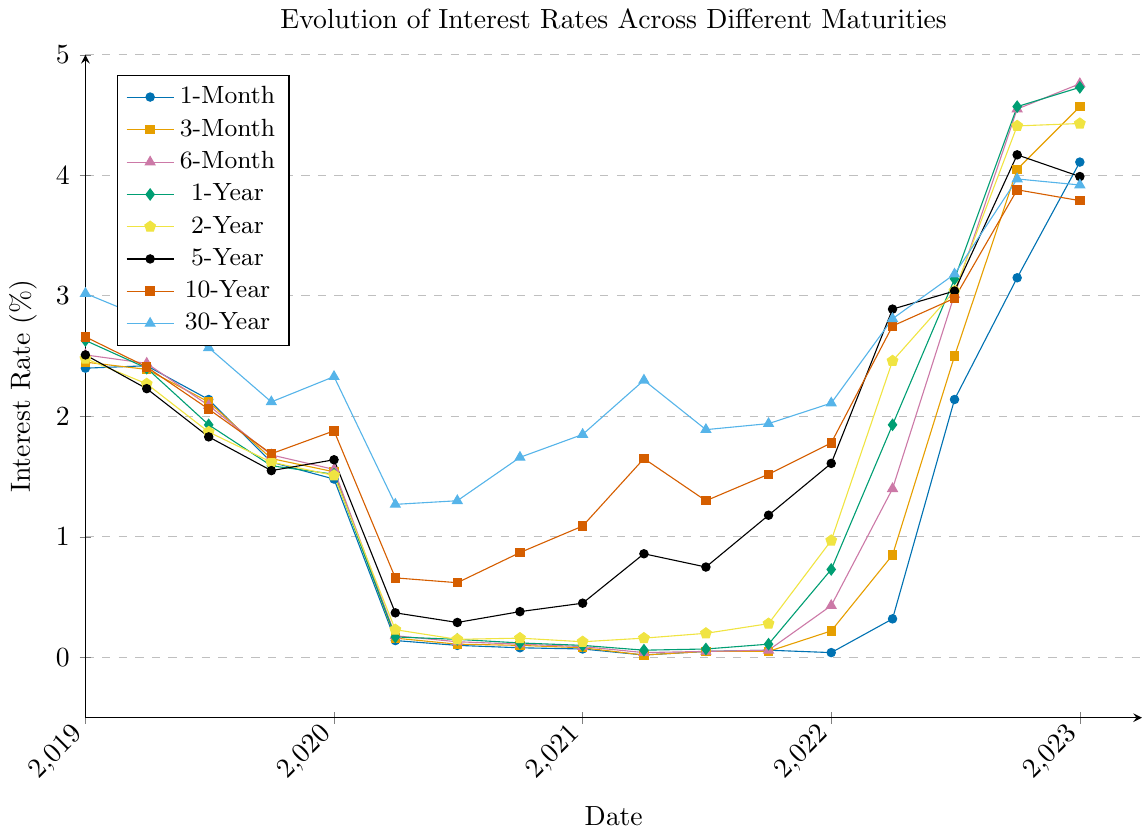Which maturity had the highest interest rate on 2019-01-01? On 2019-01-01, the 30-Year maturity had the highest interest rate. To determine this, look at the data for this date and compare the rates for all maturities.
Answer: 30-Year Which period saw the steepest increase in the 1-Month interest rate? From the figure, observe the 1-Month interest rate line. The steepest increase is between 2022-01-01 and 2023-01-01 as the rate climbs from 0.04 to 4.11.
Answer: 2022-01-01 to 2023-01-01 What was the average interest rate of the 5-Year maturity in 2021? The interest rates for the 5-Year maturity in 2021 are 0.45, 0.86, 0.75, and 1.18. Sum these values (3.24), then divide by 4 (number of data points). Steps: 0.45 + 0.86 + 0.75 + 1.18 = 3.24; 3.24 / 4 = 0.81.
Answer: 0.81 How did the 10-Year interest rate change from 2020-04-01 to 2020-10-01? On 2020-04-01, the 10-Year rate was 0.66, and on 2020-10-01 it was 0.87. The change is calculated as 0.87 - 0.66.
Answer: 0.21 increase Which maturity had the most volatile interest rate throughout the period? Volatility can be gauged by observing the line with the most fluctuations. The 3-Month maturity shows significant ups and downs throughout the chart.
Answer: 3-Month During which year did the 2-Year maturity rate first surpass 1%? From the graph, observe the 2-Year interest rate line. It surpasses 1% in 2022.
Answer: 2022 Which two maturities had the closest interest rates on 2023-01-01? Compare the interest rates for all maturities on 2023-01-01. The 5-Year and 10-Year rates are closest with values 3.99 and 3.79 respectively.
Answer: 5-Year and 10-Year By how much did the 30-Year rate change from 2020-07-01 to 2022-07-01? Check the 30-Year rate on these dates: 1.30 on 2020-07-01 and 3.18 on 2022-07-01. The change is calculated as 3.18 - 1.30.
Answer: 1.88 increase When did the 1-Year interest rate first drop below 1%? On examining the chart for the 1-Year rate, it first drops below 1% after 2020-01-01 and reaches 0.17 by 2020-04-01.
Answer: 2020-04-01 